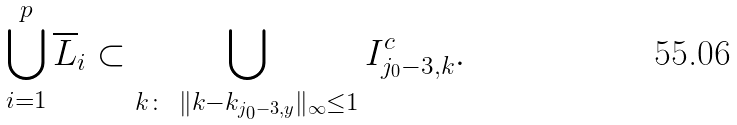<formula> <loc_0><loc_0><loc_500><loc_500>\bigcup _ { i = 1 } ^ { p } \overline { L } _ { i } \subset \bigcup _ { { k } \colon \ \| { k } - { k } _ { j _ { 0 } - 3 , y } \| _ { \infty } \leq 1 } I _ { j _ { 0 } - 3 , { k } } ^ { c } .</formula> 